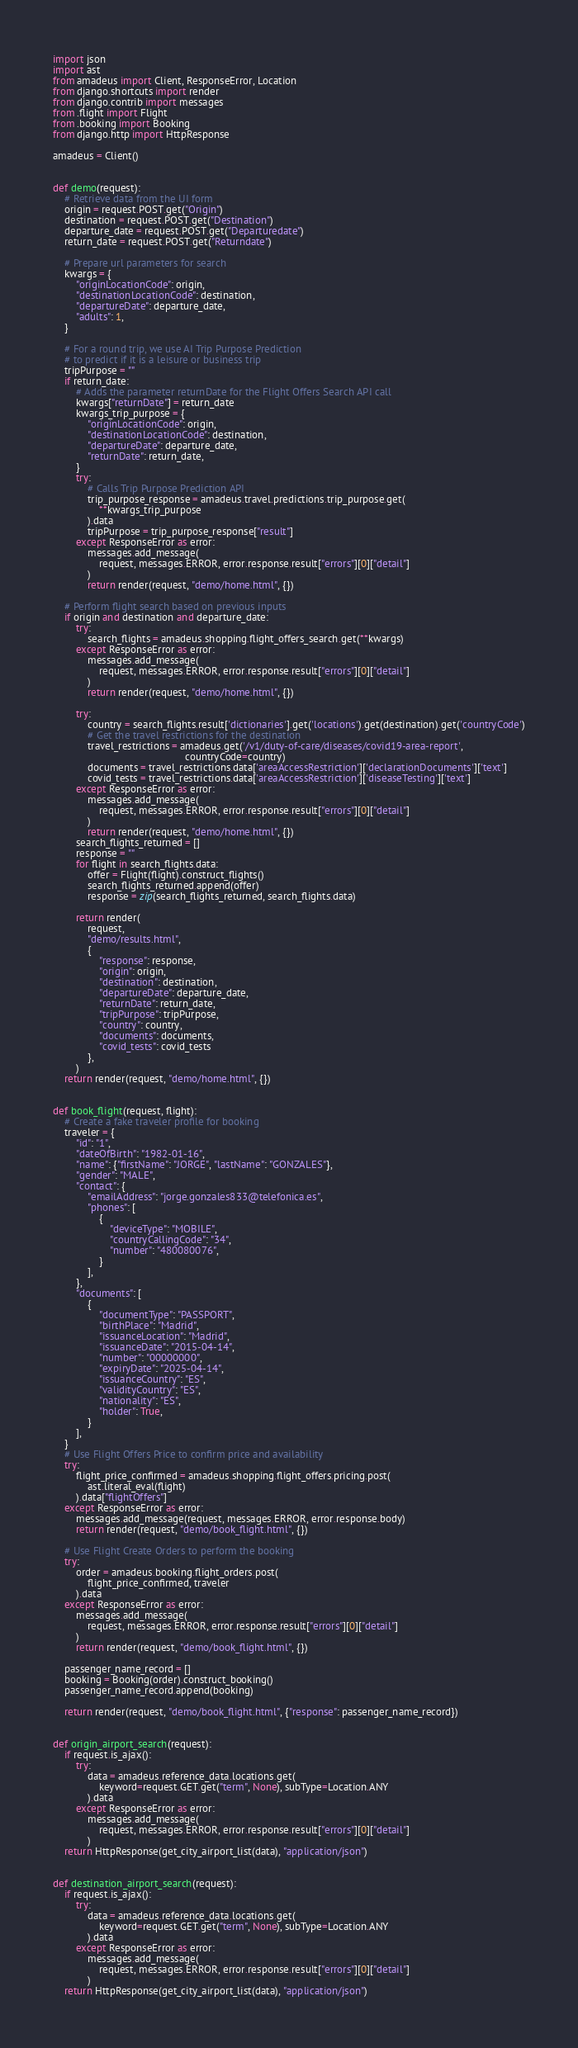Convert code to text. <code><loc_0><loc_0><loc_500><loc_500><_Python_>import json
import ast
from amadeus import Client, ResponseError, Location
from django.shortcuts import render
from django.contrib import messages
from .flight import Flight
from .booking import Booking
from django.http import HttpResponse

amadeus = Client()


def demo(request):
    # Retrieve data from the UI form
    origin = request.POST.get("Origin")
    destination = request.POST.get("Destination")
    departure_date = request.POST.get("Departuredate")
    return_date = request.POST.get("Returndate")

    # Prepare url parameters for search
    kwargs = {
        "originLocationCode": origin,
        "destinationLocationCode": destination,
        "departureDate": departure_date,
        "adults": 1,
    }

    # For a round trip, we use AI Trip Purpose Prediction
    # to predict if it is a leisure or business trip
    tripPurpose = ""
    if return_date:
        # Adds the parameter returnDate for the Flight Offers Search API call
        kwargs["returnDate"] = return_date
        kwargs_trip_purpose = {
            "originLocationCode": origin,
            "destinationLocationCode": destination,
            "departureDate": departure_date,
            "returnDate": return_date,
        }
        try:
            # Calls Trip Purpose Prediction API
            trip_purpose_response = amadeus.travel.predictions.trip_purpose.get(
                **kwargs_trip_purpose
            ).data
            tripPurpose = trip_purpose_response["result"]
        except ResponseError as error:
            messages.add_message(
                request, messages.ERROR, error.response.result["errors"][0]["detail"]
            )
            return render(request, "demo/home.html", {})

    # Perform flight search based on previous inputs
    if origin and destination and departure_date:
        try:
            search_flights = amadeus.shopping.flight_offers_search.get(**kwargs)
        except ResponseError as error:
            messages.add_message(
                request, messages.ERROR, error.response.result["errors"][0]["detail"]
            )
            return render(request, "demo/home.html", {})

        try:
            country = search_flights.result['dictionaries'].get('locations').get(destination).get('countryCode')
            # Get the travel restrictions for the destination
            travel_restrictions = amadeus.get('/v1/duty-of-care/diseases/covid19-area-report',
                                              countryCode=country)
            documents = travel_restrictions.data['areaAccessRestriction']['declarationDocuments']['text']
            covid_tests = travel_restrictions.data['areaAccessRestriction']['diseaseTesting']['text']
        except ResponseError as error:
            messages.add_message(
                request, messages.ERROR, error.response.result["errors"][0]["detail"]
            )
            return render(request, "demo/home.html", {})
        search_flights_returned = []
        response = ""
        for flight in search_flights.data:
            offer = Flight(flight).construct_flights()
            search_flights_returned.append(offer)
            response = zip(search_flights_returned, search_flights.data)

        return render(
            request,
            "demo/results.html",
            {
                "response": response,
                "origin": origin,
                "destination": destination,
                "departureDate": departure_date,
                "returnDate": return_date,
                "tripPurpose": tripPurpose,
                "country": country,
                "documents": documents,
                "covid_tests": covid_tests
            },
        )
    return render(request, "demo/home.html", {})


def book_flight(request, flight):
    # Create a fake traveler profile for booking
    traveler = {
        "id": "1",
        "dateOfBirth": "1982-01-16",
        "name": {"firstName": "JORGE", "lastName": "GONZALES"},
        "gender": "MALE",
        "contact": {
            "emailAddress": "jorge.gonzales833@telefonica.es",
            "phones": [
                {
                    "deviceType": "MOBILE",
                    "countryCallingCode": "34",
                    "number": "480080076",
                }
            ],
        },
        "documents": [
            {
                "documentType": "PASSPORT",
                "birthPlace": "Madrid",
                "issuanceLocation": "Madrid",
                "issuanceDate": "2015-04-14",
                "number": "00000000",
                "expiryDate": "2025-04-14",
                "issuanceCountry": "ES",
                "validityCountry": "ES",
                "nationality": "ES",
                "holder": True,
            }
        ],
    }
    # Use Flight Offers Price to confirm price and availability
    try:
        flight_price_confirmed = amadeus.shopping.flight_offers.pricing.post(
            ast.literal_eval(flight)
        ).data["flightOffers"]
    except ResponseError as error:
        messages.add_message(request, messages.ERROR, error.response.body)
        return render(request, "demo/book_flight.html", {})

    # Use Flight Create Orders to perform the booking
    try:
        order = amadeus.booking.flight_orders.post(
            flight_price_confirmed, traveler
        ).data
    except ResponseError as error:
        messages.add_message(
            request, messages.ERROR, error.response.result["errors"][0]["detail"]
        )
        return render(request, "demo/book_flight.html", {})

    passenger_name_record = []
    booking = Booking(order).construct_booking()
    passenger_name_record.append(booking)

    return render(request, "demo/book_flight.html", {"response": passenger_name_record})


def origin_airport_search(request):
    if request.is_ajax():
        try:
            data = amadeus.reference_data.locations.get(
                keyword=request.GET.get("term", None), subType=Location.ANY
            ).data
        except ResponseError as error:
            messages.add_message(
                request, messages.ERROR, error.response.result["errors"][0]["detail"]
            )
    return HttpResponse(get_city_airport_list(data), "application/json")


def destination_airport_search(request):
    if request.is_ajax():
        try:
            data = amadeus.reference_data.locations.get(
                keyword=request.GET.get("term", None), subType=Location.ANY
            ).data
        except ResponseError as error:
            messages.add_message(
                request, messages.ERROR, error.response.result["errors"][0]["detail"]
            )
    return HttpResponse(get_city_airport_list(data), "application/json")

</code> 